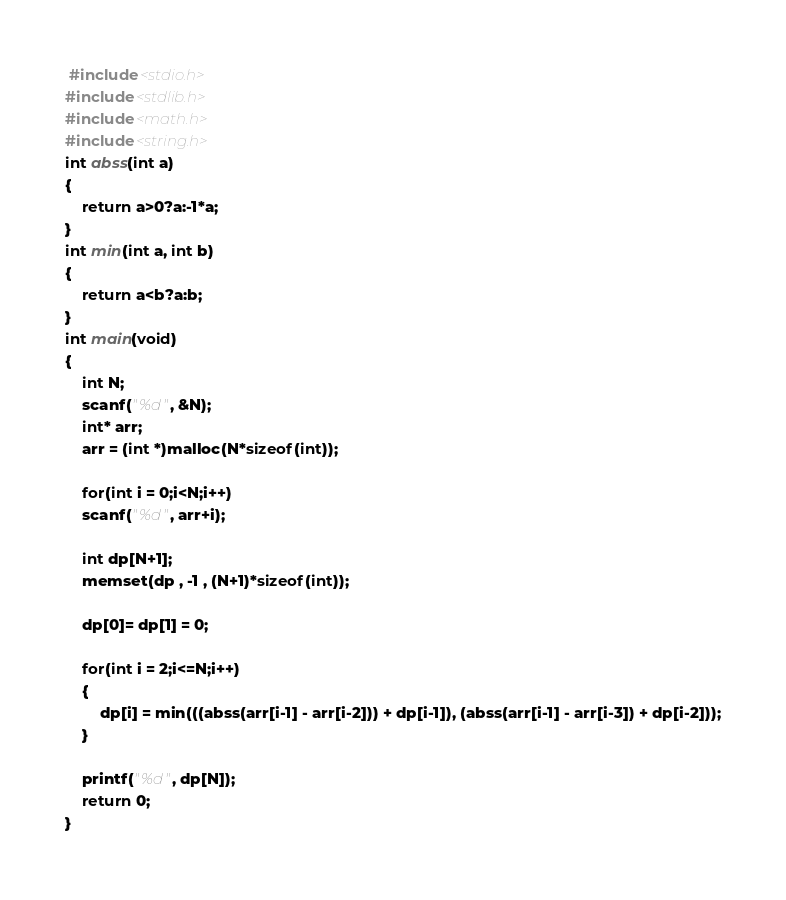<code> <loc_0><loc_0><loc_500><loc_500><_C_> #include<stdio.h>
#include<stdlib.h>
#include<math.h>
#include<string.h>
int abss(int a)
{
	return a>0?a:-1*a;
}
int min(int a, int b)
{
	return a<b?a:b;
}
int main(void)
{
	int N;
	scanf("%d", &N);
	int* arr;
	arr = (int *)malloc(N*sizeof(int));
	
	for(int i = 0;i<N;i++)
	scanf("%d", arr+i);
	
	int dp[N+1];
	memset(dp , -1 , (N+1)*sizeof(int));
	
	dp[0]= dp[1] = 0;

	for(int i = 2;i<=N;i++)
	{
		dp[i] = min(((abss(arr[i-1] - arr[i-2])) + dp[i-1]), (abss(arr[i-1] - arr[i-3]) + dp[i-2]));
	}

	printf("%d", dp[N]);
	return 0;
}
</code> 